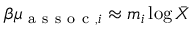Convert formula to latex. <formula><loc_0><loc_0><loc_500><loc_500>{ \beta \mu _ { a s s o c , i } \approx m _ { i } \log \bar { X } }</formula> 